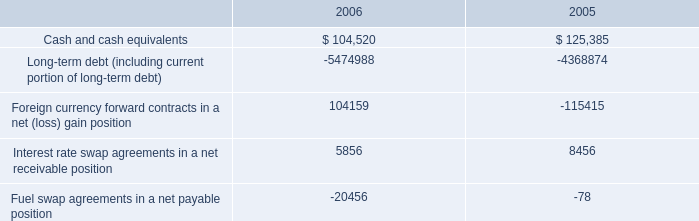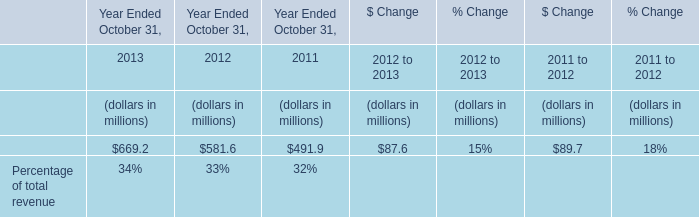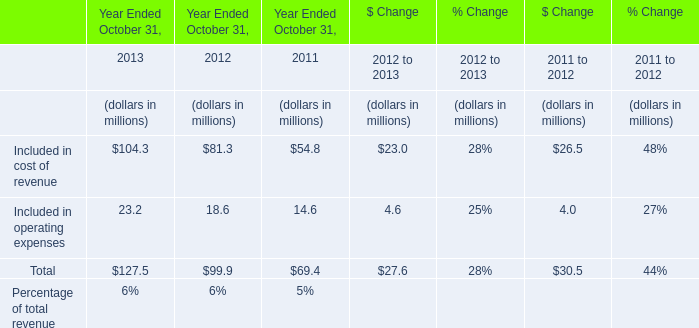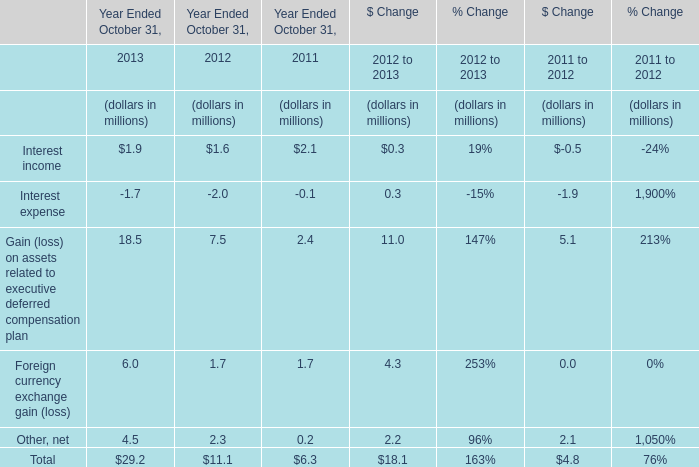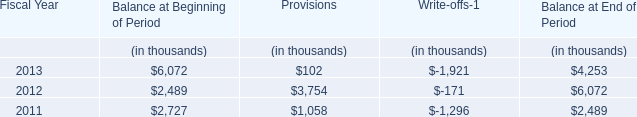As As the chart 2 shows,what is the value of the "Included in operating expenses" in 2011 Ended October 31? (in million) 
Answer: 14.6. 